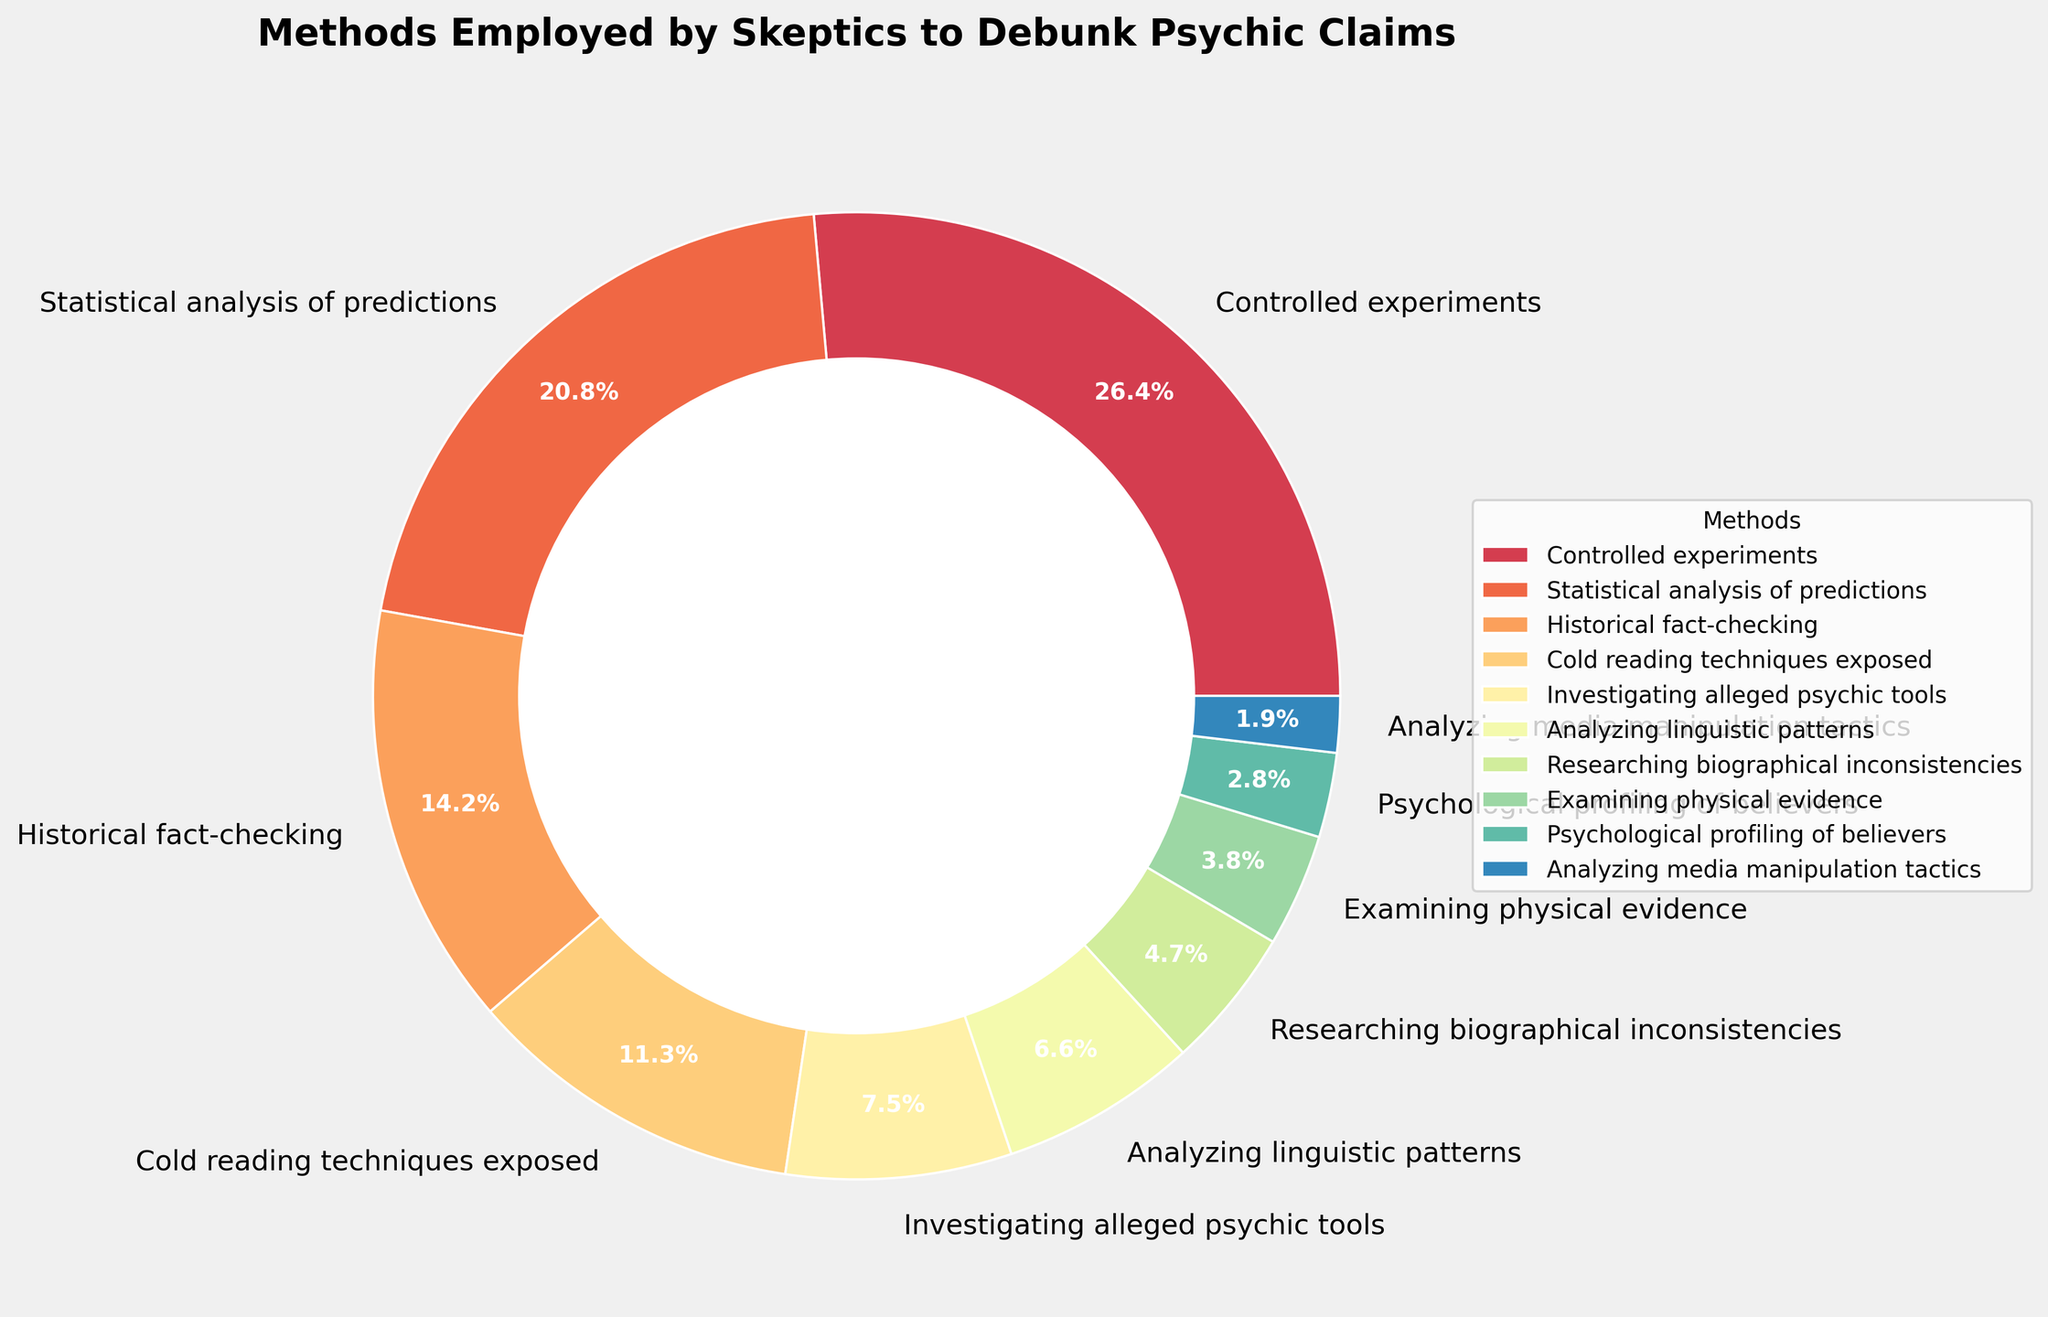Which method do skeptics use most frequently to debunk psychic claims? The pie chart shows that 'Controlled experiments' has the largest percentage slice at 28%.
Answer: Controlled experiments Which two methods are employed the least by skeptics? The smallest slices are for 'Psychological profiling of believers' at 3% and 'Analyzing media manipulation tactics' at 2%.
Answer: Psychological profiling of believers and Analyzing media manipulation tactics What is the combined percentage of 'Statistical analysis of predictions' and 'Historical fact-checking'? From the chart, 'Statistical analysis of predictions' is 22% and 'Historical fact-checking' is 15%. Therefore, 22% + 15% = 37%.
Answer: 37% Are there more skeptics employing 'Investigating alleged psychic tools' or 'Analyzing linguistic patterns'? The slice for 'Investigating alleged psychic tools' is 8%, while 'Analyzing linguistic patterns' is 7%, so more skeptics employ 'Investigating alleged psychic tools'.
Answer: Investigating alleged psychic tools How much larger is the percentage for 'Controlled experiments' compared to 'Cold reading techniques exposed'? 'Controlled experiments' is 28% and 'Cold reading techniques exposed' is 12%. The difference is 28% - 12% = 16%.
Answer: 16% What is the median percentage of all methods shown in the chart? To find the median, list the percentages in ascending order: 2, 3, 4, 5, 7, 8, 12, 15, 22, 28. The middle values are 7 and 8, whose median is (7+8)/2 = 7.5%.
Answer: 7.5% Which methods make up less than 10% each? According to the chart, 'Cold reading techniques exposed', 'Investigating alleged psychic tools', 'Analyzing linguistic patterns', 'Researching biographical inconsistencies', 'Examining physical evidence', 'Psychological profiling of believers', and 'Analyzing media manipulation tactics' all have percentages below 10%.
Answer: Cold reading techniques exposed, Investigating alleged psychic tools, Analyzing linguistic patterns, Researching biographical inconsistencies, Examining physical evidence, Psychological profiling of believers, Analyzing media manipulation tactics By how much does 'Historical fact-checking' exceed 'Examining physical evidence' in percentage? 'Historical fact-checking' has a slice of 15% and 'Examining physical evidence' has a slice of 4%. Their difference is 15% - 4% = 11%.
Answer: 11% 